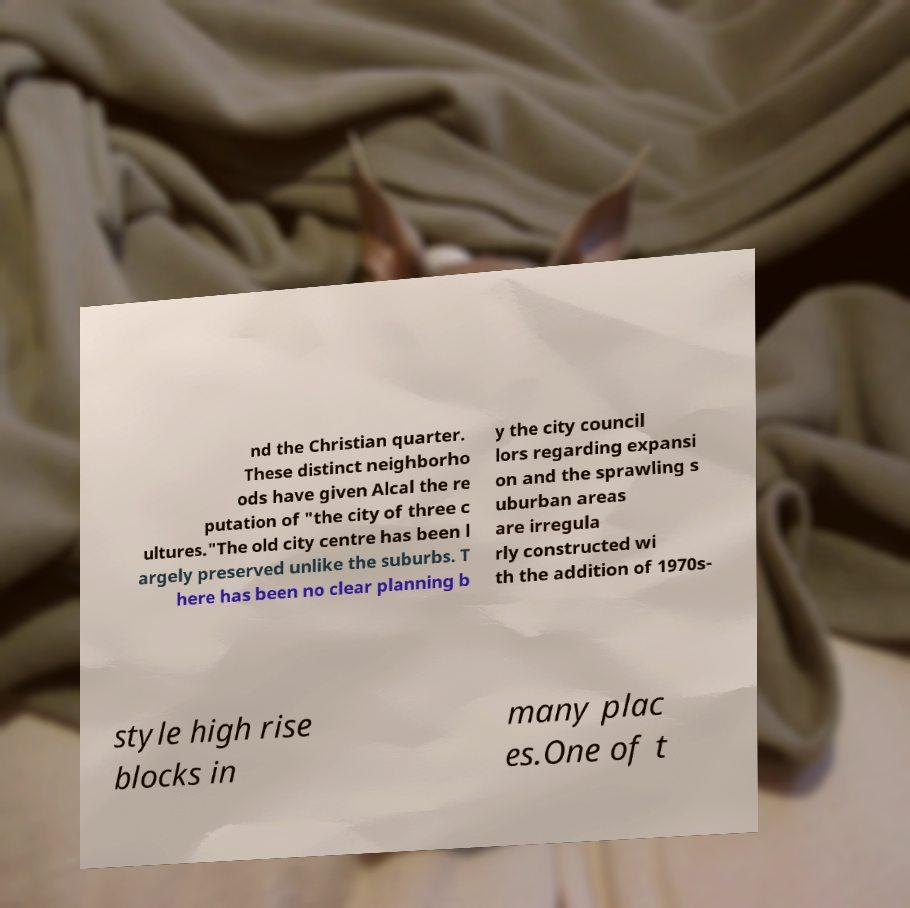Can you read and provide the text displayed in the image?This photo seems to have some interesting text. Can you extract and type it out for me? nd the Christian quarter. These distinct neighborho ods have given Alcal the re putation of "the city of three c ultures."The old city centre has been l argely preserved unlike the suburbs. T here has been no clear planning b y the city council lors regarding expansi on and the sprawling s uburban areas are irregula rly constructed wi th the addition of 1970s- style high rise blocks in many plac es.One of t 